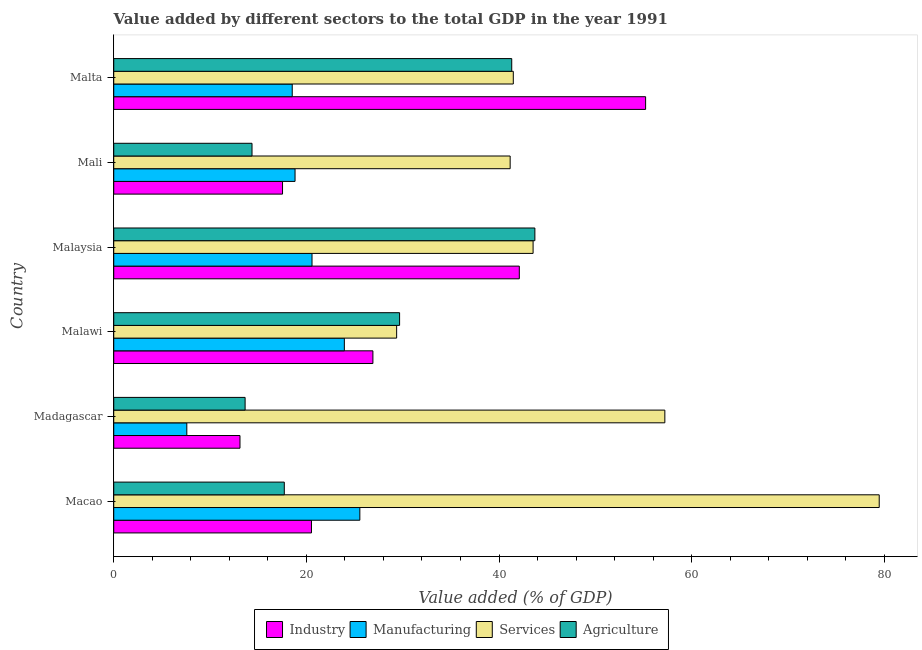How many groups of bars are there?
Your response must be concise. 6. Are the number of bars on each tick of the Y-axis equal?
Your response must be concise. Yes. How many bars are there on the 1st tick from the top?
Your response must be concise. 4. How many bars are there on the 3rd tick from the bottom?
Give a very brief answer. 4. What is the label of the 4th group of bars from the top?
Your answer should be very brief. Malawi. What is the value added by agricultural sector in Malta?
Provide a succinct answer. 41.32. Across all countries, what is the maximum value added by services sector?
Your response must be concise. 79.47. Across all countries, what is the minimum value added by industrial sector?
Ensure brevity in your answer.  13.11. In which country was the value added by agricultural sector maximum?
Your answer should be very brief. Malaysia. In which country was the value added by services sector minimum?
Your answer should be very brief. Malawi. What is the total value added by services sector in the graph?
Your answer should be compact. 292.24. What is the difference between the value added by services sector in Malawi and that in Malaysia?
Your response must be concise. -14.17. What is the difference between the value added by industrial sector in Malaysia and the value added by agricultural sector in Malawi?
Give a very brief answer. 12.43. What is the average value added by industrial sector per country?
Make the answer very short. 29.23. What is the difference between the value added by services sector and value added by industrial sector in Malaysia?
Give a very brief answer. 1.43. In how many countries, is the value added by agricultural sector greater than 64 %?
Your answer should be compact. 0. What is the ratio of the value added by industrial sector in Macao to that in Madagascar?
Keep it short and to the point. 1.57. What is the difference between the highest and the second highest value added by agricultural sector?
Offer a terse response. 2.4. What is the difference between the highest and the lowest value added by manufacturing sector?
Keep it short and to the point. 17.96. Is it the case that in every country, the sum of the value added by services sector and value added by industrial sector is greater than the sum of value added by manufacturing sector and value added by agricultural sector?
Give a very brief answer. Yes. What does the 3rd bar from the top in Malaysia represents?
Ensure brevity in your answer.  Manufacturing. What does the 4th bar from the bottom in Malawi represents?
Make the answer very short. Agriculture. Does the graph contain any zero values?
Ensure brevity in your answer.  No. Does the graph contain grids?
Your answer should be compact. No. Where does the legend appear in the graph?
Make the answer very short. Bottom center. How many legend labels are there?
Make the answer very short. 4. How are the legend labels stacked?
Provide a short and direct response. Horizontal. What is the title of the graph?
Your response must be concise. Value added by different sectors to the total GDP in the year 1991. Does "Second 20% of population" appear as one of the legend labels in the graph?
Keep it short and to the point. No. What is the label or title of the X-axis?
Your answer should be very brief. Value added (% of GDP). What is the Value added (% of GDP) of Industry in Macao?
Offer a terse response. 20.53. What is the Value added (% of GDP) of Manufacturing in Macao?
Your answer should be compact. 25.55. What is the Value added (% of GDP) of Services in Macao?
Give a very brief answer. 79.47. What is the Value added (% of GDP) of Agriculture in Macao?
Provide a short and direct response. 17.71. What is the Value added (% of GDP) of Industry in Madagascar?
Ensure brevity in your answer.  13.11. What is the Value added (% of GDP) in Manufacturing in Madagascar?
Your answer should be very brief. 7.59. What is the Value added (% of GDP) in Services in Madagascar?
Your answer should be compact. 57.22. What is the Value added (% of GDP) of Agriculture in Madagascar?
Provide a succinct answer. 13.64. What is the Value added (% of GDP) of Industry in Malawi?
Provide a succinct answer. 26.91. What is the Value added (% of GDP) in Manufacturing in Malawi?
Your response must be concise. 23.94. What is the Value added (% of GDP) in Services in Malawi?
Make the answer very short. 29.37. What is the Value added (% of GDP) in Agriculture in Malawi?
Give a very brief answer. 29.68. What is the Value added (% of GDP) of Industry in Malaysia?
Keep it short and to the point. 42.11. What is the Value added (% of GDP) in Manufacturing in Malaysia?
Offer a very short reply. 20.59. What is the Value added (% of GDP) in Services in Malaysia?
Make the answer very short. 43.54. What is the Value added (% of GDP) in Agriculture in Malaysia?
Offer a terse response. 43.72. What is the Value added (% of GDP) of Industry in Mali?
Ensure brevity in your answer.  17.52. What is the Value added (% of GDP) of Manufacturing in Mali?
Make the answer very short. 18.82. What is the Value added (% of GDP) of Services in Mali?
Keep it short and to the point. 41.16. What is the Value added (% of GDP) of Agriculture in Mali?
Make the answer very short. 14.36. What is the Value added (% of GDP) in Industry in Malta?
Keep it short and to the point. 55.22. What is the Value added (% of GDP) of Manufacturing in Malta?
Your answer should be very brief. 18.53. What is the Value added (% of GDP) in Services in Malta?
Provide a succinct answer. 41.48. What is the Value added (% of GDP) in Agriculture in Malta?
Offer a terse response. 41.32. Across all countries, what is the maximum Value added (% of GDP) of Industry?
Make the answer very short. 55.22. Across all countries, what is the maximum Value added (% of GDP) in Manufacturing?
Your answer should be compact. 25.55. Across all countries, what is the maximum Value added (% of GDP) of Services?
Offer a very short reply. 79.47. Across all countries, what is the maximum Value added (% of GDP) in Agriculture?
Provide a short and direct response. 43.72. Across all countries, what is the minimum Value added (% of GDP) of Industry?
Your answer should be very brief. 13.11. Across all countries, what is the minimum Value added (% of GDP) in Manufacturing?
Make the answer very short. 7.59. Across all countries, what is the minimum Value added (% of GDP) of Services?
Give a very brief answer. 29.37. Across all countries, what is the minimum Value added (% of GDP) of Agriculture?
Offer a very short reply. 13.64. What is the total Value added (% of GDP) in Industry in the graph?
Offer a terse response. 175.39. What is the total Value added (% of GDP) of Manufacturing in the graph?
Your response must be concise. 115.02. What is the total Value added (% of GDP) in Services in the graph?
Your response must be concise. 292.24. What is the total Value added (% of GDP) of Agriculture in the graph?
Offer a terse response. 160.42. What is the difference between the Value added (% of GDP) in Industry in Macao and that in Madagascar?
Provide a short and direct response. 7.42. What is the difference between the Value added (% of GDP) in Manufacturing in Macao and that in Madagascar?
Your answer should be compact. 17.96. What is the difference between the Value added (% of GDP) in Services in Macao and that in Madagascar?
Your answer should be compact. 22.26. What is the difference between the Value added (% of GDP) of Agriculture in Macao and that in Madagascar?
Your answer should be compact. 4.07. What is the difference between the Value added (% of GDP) in Industry in Macao and that in Malawi?
Make the answer very short. -6.38. What is the difference between the Value added (% of GDP) in Manufacturing in Macao and that in Malawi?
Keep it short and to the point. 1.61. What is the difference between the Value added (% of GDP) of Services in Macao and that in Malawi?
Ensure brevity in your answer.  50.1. What is the difference between the Value added (% of GDP) of Agriculture in Macao and that in Malawi?
Ensure brevity in your answer.  -11.97. What is the difference between the Value added (% of GDP) in Industry in Macao and that in Malaysia?
Ensure brevity in your answer.  -21.58. What is the difference between the Value added (% of GDP) in Manufacturing in Macao and that in Malaysia?
Your response must be concise. 4.96. What is the difference between the Value added (% of GDP) in Services in Macao and that in Malaysia?
Keep it short and to the point. 35.93. What is the difference between the Value added (% of GDP) in Agriculture in Macao and that in Malaysia?
Ensure brevity in your answer.  -26.01. What is the difference between the Value added (% of GDP) in Industry in Macao and that in Mali?
Ensure brevity in your answer.  3. What is the difference between the Value added (% of GDP) in Manufacturing in Macao and that in Mali?
Keep it short and to the point. 6.73. What is the difference between the Value added (% of GDP) of Services in Macao and that in Mali?
Make the answer very short. 38.32. What is the difference between the Value added (% of GDP) in Agriculture in Macao and that in Mali?
Provide a succinct answer. 3.35. What is the difference between the Value added (% of GDP) of Industry in Macao and that in Malta?
Your answer should be compact. -34.69. What is the difference between the Value added (% of GDP) in Manufacturing in Macao and that in Malta?
Provide a short and direct response. 7.02. What is the difference between the Value added (% of GDP) of Services in Macao and that in Malta?
Offer a very short reply. 37.99. What is the difference between the Value added (% of GDP) of Agriculture in Macao and that in Malta?
Your response must be concise. -23.61. What is the difference between the Value added (% of GDP) in Industry in Madagascar and that in Malawi?
Offer a very short reply. -13.8. What is the difference between the Value added (% of GDP) of Manufacturing in Madagascar and that in Malawi?
Give a very brief answer. -16.36. What is the difference between the Value added (% of GDP) of Services in Madagascar and that in Malawi?
Your answer should be compact. 27.85. What is the difference between the Value added (% of GDP) of Agriculture in Madagascar and that in Malawi?
Your response must be concise. -16.04. What is the difference between the Value added (% of GDP) in Industry in Madagascar and that in Malaysia?
Provide a short and direct response. -29. What is the difference between the Value added (% of GDP) in Manufacturing in Madagascar and that in Malaysia?
Your answer should be compact. -13. What is the difference between the Value added (% of GDP) in Services in Madagascar and that in Malaysia?
Offer a very short reply. 13.68. What is the difference between the Value added (% of GDP) of Agriculture in Madagascar and that in Malaysia?
Offer a very short reply. -30.08. What is the difference between the Value added (% of GDP) of Industry in Madagascar and that in Mali?
Give a very brief answer. -4.42. What is the difference between the Value added (% of GDP) of Manufacturing in Madagascar and that in Mali?
Provide a short and direct response. -11.24. What is the difference between the Value added (% of GDP) of Services in Madagascar and that in Mali?
Provide a short and direct response. 16.06. What is the difference between the Value added (% of GDP) in Agriculture in Madagascar and that in Mali?
Give a very brief answer. -0.72. What is the difference between the Value added (% of GDP) in Industry in Madagascar and that in Malta?
Offer a very short reply. -42.11. What is the difference between the Value added (% of GDP) in Manufacturing in Madagascar and that in Malta?
Keep it short and to the point. -10.95. What is the difference between the Value added (% of GDP) in Services in Madagascar and that in Malta?
Your answer should be very brief. 15.73. What is the difference between the Value added (% of GDP) in Agriculture in Madagascar and that in Malta?
Offer a terse response. -27.68. What is the difference between the Value added (% of GDP) of Industry in Malawi and that in Malaysia?
Provide a short and direct response. -15.2. What is the difference between the Value added (% of GDP) in Manufacturing in Malawi and that in Malaysia?
Make the answer very short. 3.36. What is the difference between the Value added (% of GDP) of Services in Malawi and that in Malaysia?
Your answer should be very brief. -14.17. What is the difference between the Value added (% of GDP) of Agriculture in Malawi and that in Malaysia?
Offer a very short reply. -14.04. What is the difference between the Value added (% of GDP) in Industry in Malawi and that in Mali?
Your response must be concise. 9.38. What is the difference between the Value added (% of GDP) of Manufacturing in Malawi and that in Mali?
Your answer should be very brief. 5.12. What is the difference between the Value added (% of GDP) of Services in Malawi and that in Mali?
Ensure brevity in your answer.  -11.79. What is the difference between the Value added (% of GDP) in Agriculture in Malawi and that in Mali?
Your answer should be very brief. 15.32. What is the difference between the Value added (% of GDP) of Industry in Malawi and that in Malta?
Offer a very short reply. -28.31. What is the difference between the Value added (% of GDP) of Manufacturing in Malawi and that in Malta?
Offer a very short reply. 5.41. What is the difference between the Value added (% of GDP) in Services in Malawi and that in Malta?
Provide a short and direct response. -12.11. What is the difference between the Value added (% of GDP) of Agriculture in Malawi and that in Malta?
Provide a succinct answer. -11.64. What is the difference between the Value added (% of GDP) in Industry in Malaysia and that in Mali?
Your answer should be compact. 24.58. What is the difference between the Value added (% of GDP) in Manufacturing in Malaysia and that in Mali?
Make the answer very short. 1.76. What is the difference between the Value added (% of GDP) of Services in Malaysia and that in Mali?
Give a very brief answer. 2.38. What is the difference between the Value added (% of GDP) in Agriculture in Malaysia and that in Mali?
Your answer should be compact. 29.37. What is the difference between the Value added (% of GDP) of Industry in Malaysia and that in Malta?
Give a very brief answer. -13.11. What is the difference between the Value added (% of GDP) in Manufacturing in Malaysia and that in Malta?
Provide a short and direct response. 2.05. What is the difference between the Value added (% of GDP) of Services in Malaysia and that in Malta?
Provide a succinct answer. 2.06. What is the difference between the Value added (% of GDP) of Agriculture in Malaysia and that in Malta?
Provide a short and direct response. 2.4. What is the difference between the Value added (% of GDP) of Industry in Mali and that in Malta?
Provide a succinct answer. -37.69. What is the difference between the Value added (% of GDP) in Manufacturing in Mali and that in Malta?
Ensure brevity in your answer.  0.29. What is the difference between the Value added (% of GDP) in Services in Mali and that in Malta?
Provide a short and direct response. -0.32. What is the difference between the Value added (% of GDP) in Agriculture in Mali and that in Malta?
Provide a succinct answer. -26.96. What is the difference between the Value added (% of GDP) of Industry in Macao and the Value added (% of GDP) of Manufacturing in Madagascar?
Provide a short and direct response. 12.94. What is the difference between the Value added (% of GDP) of Industry in Macao and the Value added (% of GDP) of Services in Madagascar?
Give a very brief answer. -36.69. What is the difference between the Value added (% of GDP) in Industry in Macao and the Value added (% of GDP) in Agriculture in Madagascar?
Your response must be concise. 6.89. What is the difference between the Value added (% of GDP) of Manufacturing in Macao and the Value added (% of GDP) of Services in Madagascar?
Provide a succinct answer. -31.67. What is the difference between the Value added (% of GDP) in Manufacturing in Macao and the Value added (% of GDP) in Agriculture in Madagascar?
Offer a terse response. 11.91. What is the difference between the Value added (% of GDP) in Services in Macao and the Value added (% of GDP) in Agriculture in Madagascar?
Give a very brief answer. 65.83. What is the difference between the Value added (% of GDP) of Industry in Macao and the Value added (% of GDP) of Manufacturing in Malawi?
Provide a succinct answer. -3.41. What is the difference between the Value added (% of GDP) in Industry in Macao and the Value added (% of GDP) in Services in Malawi?
Your answer should be compact. -8.84. What is the difference between the Value added (% of GDP) in Industry in Macao and the Value added (% of GDP) in Agriculture in Malawi?
Make the answer very short. -9.15. What is the difference between the Value added (% of GDP) of Manufacturing in Macao and the Value added (% of GDP) of Services in Malawi?
Ensure brevity in your answer.  -3.82. What is the difference between the Value added (% of GDP) of Manufacturing in Macao and the Value added (% of GDP) of Agriculture in Malawi?
Provide a short and direct response. -4.13. What is the difference between the Value added (% of GDP) in Services in Macao and the Value added (% of GDP) in Agriculture in Malawi?
Provide a succinct answer. 49.79. What is the difference between the Value added (% of GDP) in Industry in Macao and the Value added (% of GDP) in Manufacturing in Malaysia?
Ensure brevity in your answer.  -0.06. What is the difference between the Value added (% of GDP) in Industry in Macao and the Value added (% of GDP) in Services in Malaysia?
Provide a succinct answer. -23.01. What is the difference between the Value added (% of GDP) in Industry in Macao and the Value added (% of GDP) in Agriculture in Malaysia?
Your response must be concise. -23.19. What is the difference between the Value added (% of GDP) in Manufacturing in Macao and the Value added (% of GDP) in Services in Malaysia?
Keep it short and to the point. -17.99. What is the difference between the Value added (% of GDP) in Manufacturing in Macao and the Value added (% of GDP) in Agriculture in Malaysia?
Provide a short and direct response. -18.17. What is the difference between the Value added (% of GDP) of Services in Macao and the Value added (% of GDP) of Agriculture in Malaysia?
Your response must be concise. 35.75. What is the difference between the Value added (% of GDP) in Industry in Macao and the Value added (% of GDP) in Manufacturing in Mali?
Ensure brevity in your answer.  1.7. What is the difference between the Value added (% of GDP) of Industry in Macao and the Value added (% of GDP) of Services in Mali?
Keep it short and to the point. -20.63. What is the difference between the Value added (% of GDP) of Industry in Macao and the Value added (% of GDP) of Agriculture in Mali?
Keep it short and to the point. 6.17. What is the difference between the Value added (% of GDP) in Manufacturing in Macao and the Value added (% of GDP) in Services in Mali?
Keep it short and to the point. -15.61. What is the difference between the Value added (% of GDP) of Manufacturing in Macao and the Value added (% of GDP) of Agriculture in Mali?
Offer a very short reply. 11.19. What is the difference between the Value added (% of GDP) in Services in Macao and the Value added (% of GDP) in Agriculture in Mali?
Make the answer very short. 65.12. What is the difference between the Value added (% of GDP) of Industry in Macao and the Value added (% of GDP) of Manufacturing in Malta?
Provide a short and direct response. 2. What is the difference between the Value added (% of GDP) in Industry in Macao and the Value added (% of GDP) in Services in Malta?
Your answer should be very brief. -20.95. What is the difference between the Value added (% of GDP) in Industry in Macao and the Value added (% of GDP) in Agriculture in Malta?
Offer a very short reply. -20.79. What is the difference between the Value added (% of GDP) in Manufacturing in Macao and the Value added (% of GDP) in Services in Malta?
Your answer should be very brief. -15.93. What is the difference between the Value added (% of GDP) of Manufacturing in Macao and the Value added (% of GDP) of Agriculture in Malta?
Make the answer very short. -15.77. What is the difference between the Value added (% of GDP) in Services in Macao and the Value added (% of GDP) in Agriculture in Malta?
Give a very brief answer. 38.15. What is the difference between the Value added (% of GDP) of Industry in Madagascar and the Value added (% of GDP) of Manufacturing in Malawi?
Offer a terse response. -10.84. What is the difference between the Value added (% of GDP) in Industry in Madagascar and the Value added (% of GDP) in Services in Malawi?
Your answer should be compact. -16.26. What is the difference between the Value added (% of GDP) in Industry in Madagascar and the Value added (% of GDP) in Agriculture in Malawi?
Your answer should be very brief. -16.57. What is the difference between the Value added (% of GDP) in Manufacturing in Madagascar and the Value added (% of GDP) in Services in Malawi?
Offer a very short reply. -21.78. What is the difference between the Value added (% of GDP) of Manufacturing in Madagascar and the Value added (% of GDP) of Agriculture in Malawi?
Keep it short and to the point. -22.09. What is the difference between the Value added (% of GDP) of Services in Madagascar and the Value added (% of GDP) of Agriculture in Malawi?
Provide a succinct answer. 27.54. What is the difference between the Value added (% of GDP) of Industry in Madagascar and the Value added (% of GDP) of Manufacturing in Malaysia?
Provide a short and direct response. -7.48. What is the difference between the Value added (% of GDP) of Industry in Madagascar and the Value added (% of GDP) of Services in Malaysia?
Your response must be concise. -30.43. What is the difference between the Value added (% of GDP) of Industry in Madagascar and the Value added (% of GDP) of Agriculture in Malaysia?
Offer a terse response. -30.62. What is the difference between the Value added (% of GDP) in Manufacturing in Madagascar and the Value added (% of GDP) in Services in Malaysia?
Your answer should be very brief. -35.95. What is the difference between the Value added (% of GDP) of Manufacturing in Madagascar and the Value added (% of GDP) of Agriculture in Malaysia?
Provide a succinct answer. -36.14. What is the difference between the Value added (% of GDP) of Services in Madagascar and the Value added (% of GDP) of Agriculture in Malaysia?
Provide a short and direct response. 13.49. What is the difference between the Value added (% of GDP) of Industry in Madagascar and the Value added (% of GDP) of Manufacturing in Mali?
Ensure brevity in your answer.  -5.72. What is the difference between the Value added (% of GDP) of Industry in Madagascar and the Value added (% of GDP) of Services in Mali?
Provide a short and direct response. -28.05. What is the difference between the Value added (% of GDP) in Industry in Madagascar and the Value added (% of GDP) in Agriculture in Mali?
Keep it short and to the point. -1.25. What is the difference between the Value added (% of GDP) of Manufacturing in Madagascar and the Value added (% of GDP) of Services in Mali?
Give a very brief answer. -33.57. What is the difference between the Value added (% of GDP) of Manufacturing in Madagascar and the Value added (% of GDP) of Agriculture in Mali?
Offer a very short reply. -6.77. What is the difference between the Value added (% of GDP) in Services in Madagascar and the Value added (% of GDP) in Agriculture in Mali?
Your answer should be very brief. 42.86. What is the difference between the Value added (% of GDP) of Industry in Madagascar and the Value added (% of GDP) of Manufacturing in Malta?
Offer a very short reply. -5.43. What is the difference between the Value added (% of GDP) of Industry in Madagascar and the Value added (% of GDP) of Services in Malta?
Your answer should be compact. -28.38. What is the difference between the Value added (% of GDP) in Industry in Madagascar and the Value added (% of GDP) in Agriculture in Malta?
Give a very brief answer. -28.21. What is the difference between the Value added (% of GDP) in Manufacturing in Madagascar and the Value added (% of GDP) in Services in Malta?
Give a very brief answer. -33.9. What is the difference between the Value added (% of GDP) in Manufacturing in Madagascar and the Value added (% of GDP) in Agriculture in Malta?
Give a very brief answer. -33.73. What is the difference between the Value added (% of GDP) in Services in Madagascar and the Value added (% of GDP) in Agriculture in Malta?
Make the answer very short. 15.9. What is the difference between the Value added (% of GDP) in Industry in Malawi and the Value added (% of GDP) in Manufacturing in Malaysia?
Your answer should be compact. 6.32. What is the difference between the Value added (% of GDP) of Industry in Malawi and the Value added (% of GDP) of Services in Malaysia?
Your answer should be compact. -16.63. What is the difference between the Value added (% of GDP) of Industry in Malawi and the Value added (% of GDP) of Agriculture in Malaysia?
Make the answer very short. -16.81. What is the difference between the Value added (% of GDP) in Manufacturing in Malawi and the Value added (% of GDP) in Services in Malaysia?
Your answer should be very brief. -19.6. What is the difference between the Value added (% of GDP) of Manufacturing in Malawi and the Value added (% of GDP) of Agriculture in Malaysia?
Provide a succinct answer. -19.78. What is the difference between the Value added (% of GDP) in Services in Malawi and the Value added (% of GDP) in Agriculture in Malaysia?
Make the answer very short. -14.35. What is the difference between the Value added (% of GDP) of Industry in Malawi and the Value added (% of GDP) of Manufacturing in Mali?
Provide a succinct answer. 8.08. What is the difference between the Value added (% of GDP) in Industry in Malawi and the Value added (% of GDP) in Services in Mali?
Ensure brevity in your answer.  -14.25. What is the difference between the Value added (% of GDP) in Industry in Malawi and the Value added (% of GDP) in Agriculture in Mali?
Your answer should be very brief. 12.55. What is the difference between the Value added (% of GDP) of Manufacturing in Malawi and the Value added (% of GDP) of Services in Mali?
Ensure brevity in your answer.  -17.22. What is the difference between the Value added (% of GDP) in Manufacturing in Malawi and the Value added (% of GDP) in Agriculture in Mali?
Provide a succinct answer. 9.59. What is the difference between the Value added (% of GDP) of Services in Malawi and the Value added (% of GDP) of Agriculture in Mali?
Your response must be concise. 15.02. What is the difference between the Value added (% of GDP) of Industry in Malawi and the Value added (% of GDP) of Manufacturing in Malta?
Keep it short and to the point. 8.38. What is the difference between the Value added (% of GDP) in Industry in Malawi and the Value added (% of GDP) in Services in Malta?
Keep it short and to the point. -14.57. What is the difference between the Value added (% of GDP) of Industry in Malawi and the Value added (% of GDP) of Agriculture in Malta?
Give a very brief answer. -14.41. What is the difference between the Value added (% of GDP) in Manufacturing in Malawi and the Value added (% of GDP) in Services in Malta?
Keep it short and to the point. -17.54. What is the difference between the Value added (% of GDP) in Manufacturing in Malawi and the Value added (% of GDP) in Agriculture in Malta?
Your answer should be very brief. -17.38. What is the difference between the Value added (% of GDP) in Services in Malawi and the Value added (% of GDP) in Agriculture in Malta?
Offer a terse response. -11.95. What is the difference between the Value added (% of GDP) in Industry in Malaysia and the Value added (% of GDP) in Manufacturing in Mali?
Give a very brief answer. 23.28. What is the difference between the Value added (% of GDP) in Industry in Malaysia and the Value added (% of GDP) in Services in Mali?
Offer a very short reply. 0.95. What is the difference between the Value added (% of GDP) in Industry in Malaysia and the Value added (% of GDP) in Agriculture in Mali?
Offer a terse response. 27.75. What is the difference between the Value added (% of GDP) in Manufacturing in Malaysia and the Value added (% of GDP) in Services in Mali?
Your response must be concise. -20.57. What is the difference between the Value added (% of GDP) in Manufacturing in Malaysia and the Value added (% of GDP) in Agriculture in Mali?
Ensure brevity in your answer.  6.23. What is the difference between the Value added (% of GDP) of Services in Malaysia and the Value added (% of GDP) of Agriculture in Mali?
Offer a terse response. 29.18. What is the difference between the Value added (% of GDP) of Industry in Malaysia and the Value added (% of GDP) of Manufacturing in Malta?
Keep it short and to the point. 23.57. What is the difference between the Value added (% of GDP) in Industry in Malaysia and the Value added (% of GDP) in Services in Malta?
Your response must be concise. 0.62. What is the difference between the Value added (% of GDP) of Industry in Malaysia and the Value added (% of GDP) of Agriculture in Malta?
Keep it short and to the point. 0.79. What is the difference between the Value added (% of GDP) in Manufacturing in Malaysia and the Value added (% of GDP) in Services in Malta?
Your answer should be compact. -20.9. What is the difference between the Value added (% of GDP) of Manufacturing in Malaysia and the Value added (% of GDP) of Agriculture in Malta?
Provide a short and direct response. -20.73. What is the difference between the Value added (% of GDP) of Services in Malaysia and the Value added (% of GDP) of Agriculture in Malta?
Make the answer very short. 2.22. What is the difference between the Value added (% of GDP) of Industry in Mali and the Value added (% of GDP) of Manufacturing in Malta?
Offer a very short reply. -1.01. What is the difference between the Value added (% of GDP) of Industry in Mali and the Value added (% of GDP) of Services in Malta?
Provide a succinct answer. -23.96. What is the difference between the Value added (% of GDP) of Industry in Mali and the Value added (% of GDP) of Agriculture in Malta?
Your answer should be very brief. -23.8. What is the difference between the Value added (% of GDP) in Manufacturing in Mali and the Value added (% of GDP) in Services in Malta?
Your answer should be very brief. -22.66. What is the difference between the Value added (% of GDP) of Manufacturing in Mali and the Value added (% of GDP) of Agriculture in Malta?
Provide a succinct answer. -22.5. What is the difference between the Value added (% of GDP) of Services in Mali and the Value added (% of GDP) of Agriculture in Malta?
Offer a terse response. -0.16. What is the average Value added (% of GDP) in Industry per country?
Give a very brief answer. 29.23. What is the average Value added (% of GDP) in Manufacturing per country?
Provide a short and direct response. 19.17. What is the average Value added (% of GDP) in Services per country?
Your answer should be compact. 48.71. What is the average Value added (% of GDP) in Agriculture per country?
Keep it short and to the point. 26.74. What is the difference between the Value added (% of GDP) in Industry and Value added (% of GDP) in Manufacturing in Macao?
Your answer should be very brief. -5.02. What is the difference between the Value added (% of GDP) in Industry and Value added (% of GDP) in Services in Macao?
Ensure brevity in your answer.  -58.94. What is the difference between the Value added (% of GDP) of Industry and Value added (% of GDP) of Agriculture in Macao?
Make the answer very short. 2.82. What is the difference between the Value added (% of GDP) of Manufacturing and Value added (% of GDP) of Services in Macao?
Provide a succinct answer. -53.92. What is the difference between the Value added (% of GDP) in Manufacturing and Value added (% of GDP) in Agriculture in Macao?
Make the answer very short. 7.84. What is the difference between the Value added (% of GDP) in Services and Value added (% of GDP) in Agriculture in Macao?
Offer a terse response. 61.77. What is the difference between the Value added (% of GDP) in Industry and Value added (% of GDP) in Manufacturing in Madagascar?
Provide a short and direct response. 5.52. What is the difference between the Value added (% of GDP) of Industry and Value added (% of GDP) of Services in Madagascar?
Give a very brief answer. -44.11. What is the difference between the Value added (% of GDP) in Industry and Value added (% of GDP) in Agriculture in Madagascar?
Offer a terse response. -0.53. What is the difference between the Value added (% of GDP) in Manufacturing and Value added (% of GDP) in Services in Madagascar?
Provide a short and direct response. -49.63. What is the difference between the Value added (% of GDP) in Manufacturing and Value added (% of GDP) in Agriculture in Madagascar?
Give a very brief answer. -6.05. What is the difference between the Value added (% of GDP) in Services and Value added (% of GDP) in Agriculture in Madagascar?
Give a very brief answer. 43.58. What is the difference between the Value added (% of GDP) in Industry and Value added (% of GDP) in Manufacturing in Malawi?
Ensure brevity in your answer.  2.97. What is the difference between the Value added (% of GDP) of Industry and Value added (% of GDP) of Services in Malawi?
Your response must be concise. -2.46. What is the difference between the Value added (% of GDP) of Industry and Value added (% of GDP) of Agriculture in Malawi?
Your answer should be compact. -2.77. What is the difference between the Value added (% of GDP) in Manufacturing and Value added (% of GDP) in Services in Malawi?
Your answer should be very brief. -5.43. What is the difference between the Value added (% of GDP) in Manufacturing and Value added (% of GDP) in Agriculture in Malawi?
Provide a short and direct response. -5.74. What is the difference between the Value added (% of GDP) of Services and Value added (% of GDP) of Agriculture in Malawi?
Offer a terse response. -0.31. What is the difference between the Value added (% of GDP) of Industry and Value added (% of GDP) of Manufacturing in Malaysia?
Offer a very short reply. 21.52. What is the difference between the Value added (% of GDP) of Industry and Value added (% of GDP) of Services in Malaysia?
Offer a terse response. -1.43. What is the difference between the Value added (% of GDP) of Industry and Value added (% of GDP) of Agriculture in Malaysia?
Keep it short and to the point. -1.62. What is the difference between the Value added (% of GDP) in Manufacturing and Value added (% of GDP) in Services in Malaysia?
Make the answer very short. -22.95. What is the difference between the Value added (% of GDP) in Manufacturing and Value added (% of GDP) in Agriculture in Malaysia?
Offer a terse response. -23.14. What is the difference between the Value added (% of GDP) in Services and Value added (% of GDP) in Agriculture in Malaysia?
Your response must be concise. -0.18. What is the difference between the Value added (% of GDP) of Industry and Value added (% of GDP) of Manufacturing in Mali?
Keep it short and to the point. -1.3. What is the difference between the Value added (% of GDP) in Industry and Value added (% of GDP) in Services in Mali?
Ensure brevity in your answer.  -23.63. What is the difference between the Value added (% of GDP) in Industry and Value added (% of GDP) in Agriculture in Mali?
Ensure brevity in your answer.  3.17. What is the difference between the Value added (% of GDP) of Manufacturing and Value added (% of GDP) of Services in Mali?
Provide a succinct answer. -22.33. What is the difference between the Value added (% of GDP) in Manufacturing and Value added (% of GDP) in Agriculture in Mali?
Your answer should be compact. 4.47. What is the difference between the Value added (% of GDP) of Services and Value added (% of GDP) of Agriculture in Mali?
Provide a succinct answer. 26.8. What is the difference between the Value added (% of GDP) in Industry and Value added (% of GDP) in Manufacturing in Malta?
Make the answer very short. 36.69. What is the difference between the Value added (% of GDP) of Industry and Value added (% of GDP) of Services in Malta?
Your response must be concise. 13.74. What is the difference between the Value added (% of GDP) of Industry and Value added (% of GDP) of Agriculture in Malta?
Offer a very short reply. 13.9. What is the difference between the Value added (% of GDP) of Manufacturing and Value added (% of GDP) of Services in Malta?
Your answer should be compact. -22.95. What is the difference between the Value added (% of GDP) in Manufacturing and Value added (% of GDP) in Agriculture in Malta?
Your response must be concise. -22.79. What is the difference between the Value added (% of GDP) of Services and Value added (% of GDP) of Agriculture in Malta?
Offer a terse response. 0.16. What is the ratio of the Value added (% of GDP) in Industry in Macao to that in Madagascar?
Your answer should be compact. 1.57. What is the ratio of the Value added (% of GDP) of Manufacturing in Macao to that in Madagascar?
Provide a short and direct response. 3.37. What is the ratio of the Value added (% of GDP) in Services in Macao to that in Madagascar?
Your answer should be very brief. 1.39. What is the ratio of the Value added (% of GDP) in Agriculture in Macao to that in Madagascar?
Keep it short and to the point. 1.3. What is the ratio of the Value added (% of GDP) of Industry in Macao to that in Malawi?
Keep it short and to the point. 0.76. What is the ratio of the Value added (% of GDP) in Manufacturing in Macao to that in Malawi?
Give a very brief answer. 1.07. What is the ratio of the Value added (% of GDP) of Services in Macao to that in Malawi?
Your answer should be compact. 2.71. What is the ratio of the Value added (% of GDP) in Agriculture in Macao to that in Malawi?
Your answer should be very brief. 0.6. What is the ratio of the Value added (% of GDP) in Industry in Macao to that in Malaysia?
Your answer should be compact. 0.49. What is the ratio of the Value added (% of GDP) in Manufacturing in Macao to that in Malaysia?
Your answer should be compact. 1.24. What is the ratio of the Value added (% of GDP) of Services in Macao to that in Malaysia?
Provide a succinct answer. 1.83. What is the ratio of the Value added (% of GDP) in Agriculture in Macao to that in Malaysia?
Provide a succinct answer. 0.41. What is the ratio of the Value added (% of GDP) of Industry in Macao to that in Mali?
Keep it short and to the point. 1.17. What is the ratio of the Value added (% of GDP) of Manufacturing in Macao to that in Mali?
Offer a very short reply. 1.36. What is the ratio of the Value added (% of GDP) of Services in Macao to that in Mali?
Give a very brief answer. 1.93. What is the ratio of the Value added (% of GDP) in Agriculture in Macao to that in Mali?
Make the answer very short. 1.23. What is the ratio of the Value added (% of GDP) of Industry in Macao to that in Malta?
Keep it short and to the point. 0.37. What is the ratio of the Value added (% of GDP) in Manufacturing in Macao to that in Malta?
Offer a very short reply. 1.38. What is the ratio of the Value added (% of GDP) in Services in Macao to that in Malta?
Keep it short and to the point. 1.92. What is the ratio of the Value added (% of GDP) of Agriculture in Macao to that in Malta?
Ensure brevity in your answer.  0.43. What is the ratio of the Value added (% of GDP) of Industry in Madagascar to that in Malawi?
Ensure brevity in your answer.  0.49. What is the ratio of the Value added (% of GDP) in Manufacturing in Madagascar to that in Malawi?
Offer a terse response. 0.32. What is the ratio of the Value added (% of GDP) of Services in Madagascar to that in Malawi?
Your response must be concise. 1.95. What is the ratio of the Value added (% of GDP) in Agriculture in Madagascar to that in Malawi?
Your answer should be compact. 0.46. What is the ratio of the Value added (% of GDP) of Industry in Madagascar to that in Malaysia?
Your answer should be compact. 0.31. What is the ratio of the Value added (% of GDP) in Manufacturing in Madagascar to that in Malaysia?
Offer a very short reply. 0.37. What is the ratio of the Value added (% of GDP) of Services in Madagascar to that in Malaysia?
Give a very brief answer. 1.31. What is the ratio of the Value added (% of GDP) in Agriculture in Madagascar to that in Malaysia?
Offer a terse response. 0.31. What is the ratio of the Value added (% of GDP) in Industry in Madagascar to that in Mali?
Offer a very short reply. 0.75. What is the ratio of the Value added (% of GDP) of Manufacturing in Madagascar to that in Mali?
Offer a terse response. 0.4. What is the ratio of the Value added (% of GDP) of Services in Madagascar to that in Mali?
Provide a short and direct response. 1.39. What is the ratio of the Value added (% of GDP) in Agriculture in Madagascar to that in Mali?
Offer a terse response. 0.95. What is the ratio of the Value added (% of GDP) in Industry in Madagascar to that in Malta?
Your response must be concise. 0.24. What is the ratio of the Value added (% of GDP) in Manufacturing in Madagascar to that in Malta?
Offer a very short reply. 0.41. What is the ratio of the Value added (% of GDP) of Services in Madagascar to that in Malta?
Provide a succinct answer. 1.38. What is the ratio of the Value added (% of GDP) in Agriculture in Madagascar to that in Malta?
Provide a short and direct response. 0.33. What is the ratio of the Value added (% of GDP) in Industry in Malawi to that in Malaysia?
Keep it short and to the point. 0.64. What is the ratio of the Value added (% of GDP) in Manufacturing in Malawi to that in Malaysia?
Ensure brevity in your answer.  1.16. What is the ratio of the Value added (% of GDP) in Services in Malawi to that in Malaysia?
Offer a very short reply. 0.67. What is the ratio of the Value added (% of GDP) of Agriculture in Malawi to that in Malaysia?
Ensure brevity in your answer.  0.68. What is the ratio of the Value added (% of GDP) in Industry in Malawi to that in Mali?
Provide a succinct answer. 1.54. What is the ratio of the Value added (% of GDP) in Manufacturing in Malawi to that in Mali?
Make the answer very short. 1.27. What is the ratio of the Value added (% of GDP) in Services in Malawi to that in Mali?
Provide a succinct answer. 0.71. What is the ratio of the Value added (% of GDP) of Agriculture in Malawi to that in Mali?
Ensure brevity in your answer.  2.07. What is the ratio of the Value added (% of GDP) in Industry in Malawi to that in Malta?
Keep it short and to the point. 0.49. What is the ratio of the Value added (% of GDP) in Manufacturing in Malawi to that in Malta?
Offer a terse response. 1.29. What is the ratio of the Value added (% of GDP) in Services in Malawi to that in Malta?
Your response must be concise. 0.71. What is the ratio of the Value added (% of GDP) of Agriculture in Malawi to that in Malta?
Ensure brevity in your answer.  0.72. What is the ratio of the Value added (% of GDP) in Industry in Malaysia to that in Mali?
Give a very brief answer. 2.4. What is the ratio of the Value added (% of GDP) in Manufacturing in Malaysia to that in Mali?
Provide a short and direct response. 1.09. What is the ratio of the Value added (% of GDP) of Services in Malaysia to that in Mali?
Your answer should be compact. 1.06. What is the ratio of the Value added (% of GDP) in Agriculture in Malaysia to that in Mali?
Make the answer very short. 3.05. What is the ratio of the Value added (% of GDP) of Industry in Malaysia to that in Malta?
Keep it short and to the point. 0.76. What is the ratio of the Value added (% of GDP) in Manufacturing in Malaysia to that in Malta?
Provide a short and direct response. 1.11. What is the ratio of the Value added (% of GDP) in Services in Malaysia to that in Malta?
Give a very brief answer. 1.05. What is the ratio of the Value added (% of GDP) of Agriculture in Malaysia to that in Malta?
Give a very brief answer. 1.06. What is the ratio of the Value added (% of GDP) in Industry in Mali to that in Malta?
Your answer should be compact. 0.32. What is the ratio of the Value added (% of GDP) of Manufacturing in Mali to that in Malta?
Offer a terse response. 1.02. What is the ratio of the Value added (% of GDP) in Agriculture in Mali to that in Malta?
Your answer should be compact. 0.35. What is the difference between the highest and the second highest Value added (% of GDP) in Industry?
Offer a very short reply. 13.11. What is the difference between the highest and the second highest Value added (% of GDP) of Manufacturing?
Provide a succinct answer. 1.61. What is the difference between the highest and the second highest Value added (% of GDP) of Services?
Your answer should be compact. 22.26. What is the difference between the highest and the second highest Value added (% of GDP) of Agriculture?
Your response must be concise. 2.4. What is the difference between the highest and the lowest Value added (% of GDP) of Industry?
Offer a terse response. 42.11. What is the difference between the highest and the lowest Value added (% of GDP) of Manufacturing?
Provide a short and direct response. 17.96. What is the difference between the highest and the lowest Value added (% of GDP) in Services?
Your response must be concise. 50.1. What is the difference between the highest and the lowest Value added (% of GDP) of Agriculture?
Keep it short and to the point. 30.08. 